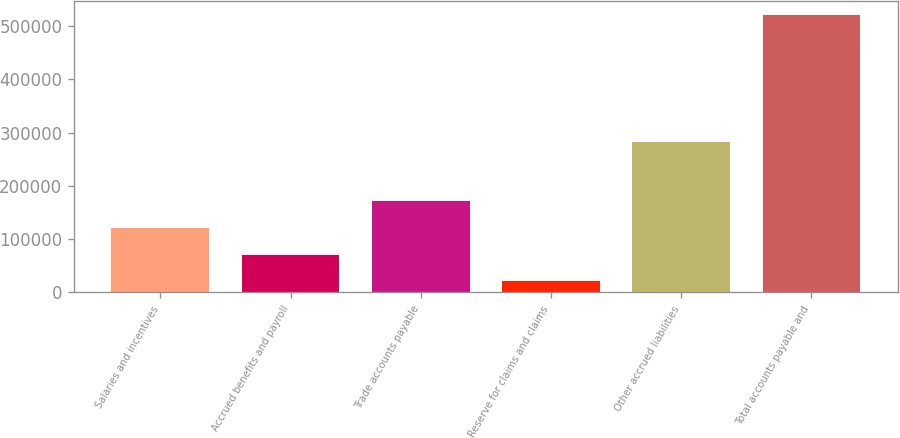Convert chart. <chart><loc_0><loc_0><loc_500><loc_500><bar_chart><fcel>Salaries and incentives<fcel>Accrued benefits and payroll<fcel>Trade accounts payable<fcel>Reserve for claims and claims<fcel>Other accrued liabilities<fcel>Total accounts payable and<nl><fcel>120870<fcel>70977.2<fcel>170764<fcel>21084<fcel>281434<fcel>520016<nl></chart> 